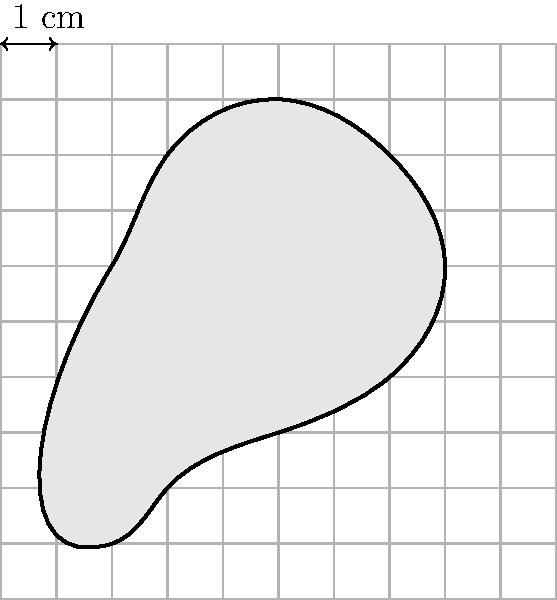You've discovered a tooth fossil from a Miocene mammal species. To estimate its size, you decide to use a grid overlay method. Each square in the grid represents 1 cm². If the fossil covers approximately 24 whole squares and 14 partial squares that are more than half filled, what is the estimated area of the fossil in square centimeters? To estimate the area of the irregularly shaped tooth fossil using the grid overlay method, we'll follow these steps:

1. Count the number of whole squares covered by the fossil:
   - Whole squares = 24

2. Count the number of partial squares that are more than half filled:
   - Partial squares (> 50% filled) = 14

3. For a conservative estimate, we'll count each partial square as 0.5 square units:
   - Area of partial squares = $14 \times 0.5 = 7$ cm²

4. Calculate the total estimated area by adding whole squares and partial squares:
   - Total area = Whole squares + Partial squares
   - Total area = $24 + 7 = 31$ cm²

Therefore, the estimated area of the Miocene mammal tooth fossil is 31 square centimeters.
Answer: 31 cm² 